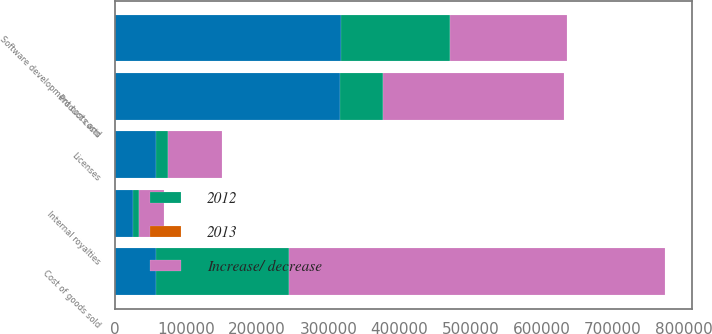Convert chart to OTSL. <chart><loc_0><loc_0><loc_500><loc_500><stacked_bar_chart><ecel><fcel>Software development costs and<fcel>Product costs<fcel>Licenses<fcel>Internal royalties<fcel>Cost of goods sold<nl><fcel>nan<fcel>317756<fcel>316072<fcel>57285<fcel>24724<fcel>57285<nl><fcel>2013<fcel>26.2<fcel>26<fcel>4.7<fcel>2<fcel>58.9<nl><fcel>Increase/ decrease<fcel>164487<fcel>255236<fcel>74976<fcel>34156<fcel>528855<nl><fcel>2012<fcel>153269<fcel>60836<fcel>17691<fcel>9432<fcel>186982<nl></chart> 